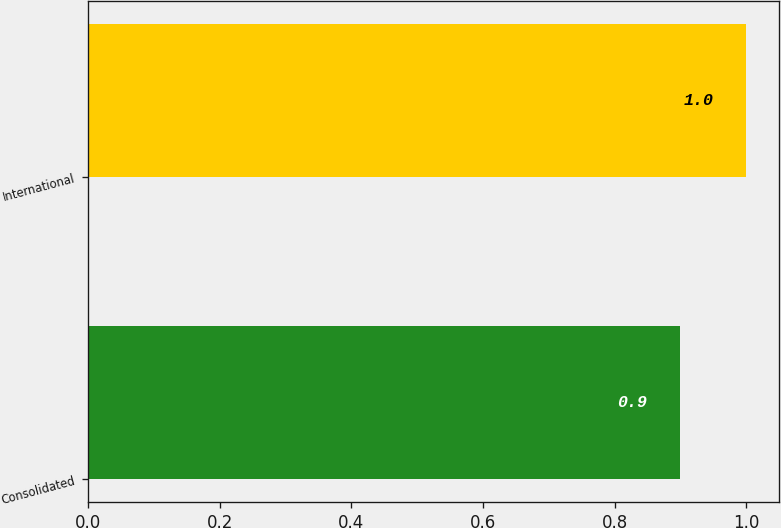Convert chart to OTSL. <chart><loc_0><loc_0><loc_500><loc_500><bar_chart><fcel>Consolidated<fcel>International<nl><fcel>0.9<fcel>1<nl></chart> 